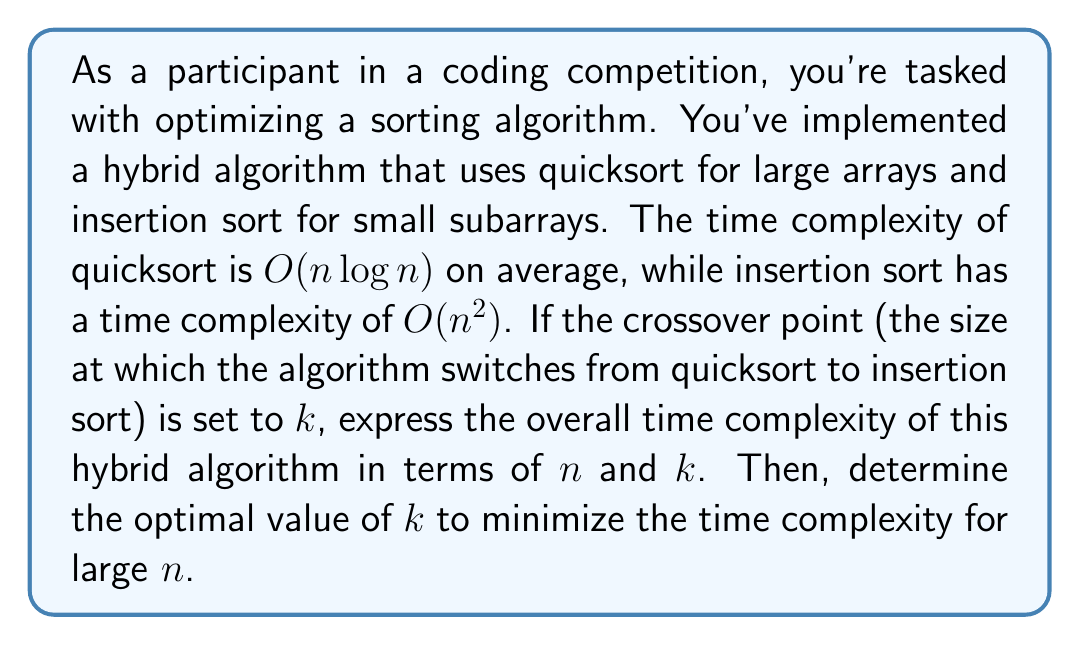Provide a solution to this math problem. Let's approach this step-by-step:

1) The hybrid algorithm uses quicksort until the subarray size reaches $k$, then switches to insertion sort.

2) The time complexity of quicksort for partitioning the array into subarrays of size $k$ is $O(n \log (n/k))$.

3) There will be $n/k$ subarrays of size $k$, each sorted using insertion sort.

4) The time complexity of insertion sort for each subarray is $O(k^2)$.

5) Thus, the total time complexity for sorting all subarrays is $O((n/k) \cdot k^2) = O(nk)$.

6) Combining steps 2 and 5, the overall time complexity is:

   $$O(n \log (n/k) + nk)$$

7) To find the optimal $k$, we need to minimize this expression. In practice, this occurs when the two terms are balanced:

   $$n \log (n/k) \approx nk$$

8) Solving this equation:

   $$\log (n/k) \approx k$$
   $$n/k \approx 2^k$$
   $$n \approx k \cdot 2^k$$

9) For large $n$, this is satisfied when $k \approx \log n$.

Therefore, the optimal value of $k$ is approximately $\log n$.
Answer: The overall time complexity of the hybrid algorithm is $O(n \log (n/k) + nk)$, and the optimal value of $k$ to minimize this complexity for large $n$ is approximately $\log n$. 